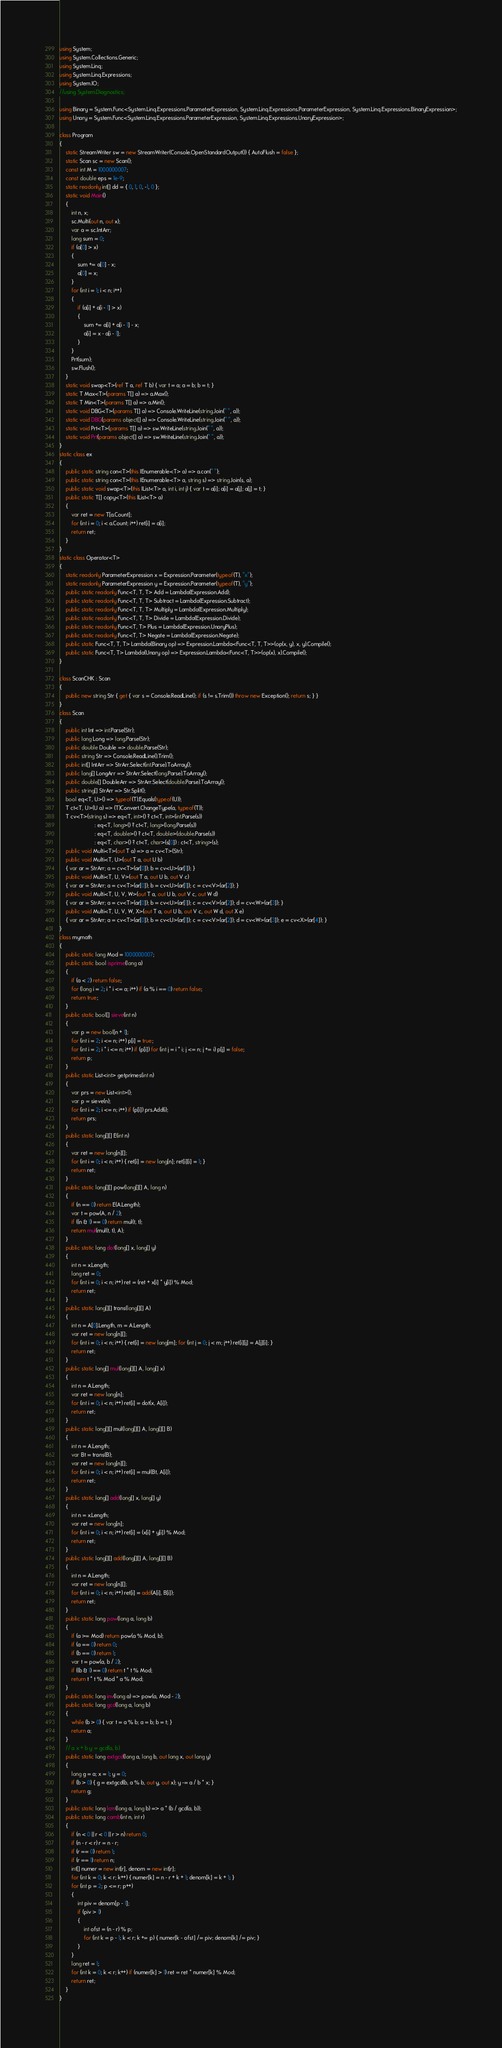<code> <loc_0><loc_0><loc_500><loc_500><_C#_>using System;
using System.Collections.Generic;
using System.Linq;
using System.Linq.Expressions;
using System.IO;
//using System.Diagnostics;

using Binary = System.Func<System.Linq.Expressions.ParameterExpression, System.Linq.Expressions.ParameterExpression, System.Linq.Expressions.BinaryExpression>;
using Unary = System.Func<System.Linq.Expressions.ParameterExpression, System.Linq.Expressions.UnaryExpression>;

class Program
{
    static StreamWriter sw = new StreamWriter(Console.OpenStandardOutput()) { AutoFlush = false };
    static Scan sc = new Scan();
    const int M = 1000000007;
    const double eps = 1e-9;
    static readonly int[] dd = { 0, 1, 0, -1, 0 };
    static void Main()
    {
        int n, x;
        sc.Multi(out n, out x);
        var a = sc.IntArr;
        long sum = 0;
        if (a[0] > x)
        {
            sum += a[0] - x;
            a[0] = x;
        }
        for (int i = 1; i < n; i++)
        {
            if (a[i] + a[i - 1] > x)
            {
                sum += a[i] + a[i - 1] - x;
                a[i] = x - a[i - 1];
            }
        }
        Prt(sum);
        sw.Flush();
    }
    static void swap<T>(ref T a, ref T b) { var t = a; a = b; b = t; }
    static T Max<T>(params T[] a) => a.Max();
    static T Min<T>(params T[] a) => a.Min();
    static void DBG<T>(params T[] a) => Console.WriteLine(string.Join(" ", a));
    static void DBG(params object[] a) => Console.WriteLine(string.Join(" ", a));
    static void Prt<T>(params T[] a) => sw.WriteLine(string.Join(" ", a));
    static void Prt(params object[] a) => sw.WriteLine(string.Join(" ", a));
}
static class ex
{
    public static string con<T>(this IEnumerable<T> a) => a.con(" ");
    public static string con<T>(this IEnumerable<T> a, string s) => string.Join(s, a);
    public static void swap<T>(this IList<T> a, int i, int j) { var t = a[i]; a[i] = a[j]; a[j] = t; }
    public static T[] copy<T>(this IList<T> a)
    {
        var ret = new T[a.Count];
        for (int i = 0; i < a.Count; i++) ret[i] = a[i];
        return ret;
    }
}
static class Operator<T>
{
    static readonly ParameterExpression x = Expression.Parameter(typeof(T), "x");
    static readonly ParameterExpression y = Expression.Parameter(typeof(T), "y");
    public static readonly Func<T, T, T> Add = Lambda(Expression.Add);
    public static readonly Func<T, T, T> Subtract = Lambda(Expression.Subtract);
    public static readonly Func<T, T, T> Multiply = Lambda(Expression.Multiply);
    public static readonly Func<T, T, T> Divide = Lambda(Expression.Divide);
    public static readonly Func<T, T> Plus = Lambda(Expression.UnaryPlus);
    public static readonly Func<T, T> Negate = Lambda(Expression.Negate);
    public static Func<T, T, T> Lambda(Binary op) => Expression.Lambda<Func<T, T, T>>(op(x, y), x, y).Compile();
    public static Func<T, T> Lambda(Unary op) => Expression.Lambda<Func<T, T>>(op(x), x).Compile();
}

class ScanCHK : Scan
{
    public new string Str { get { var s = Console.ReadLine(); if (s != s.Trim()) throw new Exception(); return s; } }
}
class Scan
{
    public int Int => int.Parse(Str);
    public long Long => long.Parse(Str);
    public double Double => double.Parse(Str);
    public string Str => Console.ReadLine().Trim();
    public int[] IntArr => StrArr.Select(int.Parse).ToArray();
    public long[] LongArr => StrArr.Select(long.Parse).ToArray();
    public double[] DoubleArr => StrArr.Select(double.Parse).ToArray();
    public string[] StrArr => Str.Split();
    bool eq<T, U>() => typeof(T).Equals(typeof(U));
    T ct<T, U>(U a) => (T)Convert.ChangeType(a, typeof(T));
    T cv<T>(string s) => eq<T, int>() ? ct<T, int>(int.Parse(s))
                       : eq<T, long>() ? ct<T, long>(long.Parse(s))
                       : eq<T, double>() ? ct<T, double>(double.Parse(s))
                       : eq<T, char>() ? ct<T, char>(s[0]) : ct<T, string>(s);
    public void Multi<T>(out T a) => a = cv<T>(Str);
    public void Multi<T, U>(out T a, out U b)
    { var ar = StrArr; a = cv<T>(ar[0]); b = cv<U>(ar[1]); }
    public void Multi<T, U, V>(out T a, out U b, out V c)
    { var ar = StrArr; a = cv<T>(ar[0]); b = cv<U>(ar[1]); c = cv<V>(ar[2]); }
    public void Multi<T, U, V, W>(out T a, out U b, out V c, out W d)
    { var ar = StrArr; a = cv<T>(ar[0]); b = cv<U>(ar[1]); c = cv<V>(ar[2]); d = cv<W>(ar[3]); }
    public void Multi<T, U, V, W, X>(out T a, out U b, out V c, out W d, out X e)
    { var ar = StrArr; a = cv<T>(ar[0]); b = cv<U>(ar[1]); c = cv<V>(ar[2]); d = cv<W>(ar[3]); e = cv<X>(ar[4]); }
}
class mymath
{
    public static long Mod = 1000000007;
    public static bool isprime(long a)
    {
        if (a < 2) return false;
        for (long i = 2; i * i <= a; i++) if (a % i == 0) return false;
        return true;
    }
    public static bool[] sieve(int n)
    {
        var p = new bool[n + 1];
        for (int i = 2; i <= n; i++) p[i] = true;
        for (int i = 2; i * i <= n; i++) if (p[i]) for (int j = i * i; j <= n; j += i) p[j] = false;
        return p;
    }
    public static List<int> getprimes(int n)
    {
        var prs = new List<int>();
        var p = sieve(n);
        for (int i = 2; i <= n; i++) if (p[i]) prs.Add(i);
        return prs;
    }
    public static long[][] E(int n)
    {
        var ret = new long[n][];
        for (int i = 0; i < n; i++) { ret[i] = new long[n]; ret[i][i] = 1; }
        return ret;
    }
    public static long[][] pow(long[][] A, long n)
    {
        if (n == 0) return E(A.Length);
        var t = pow(A, n / 2);
        if ((n & 1) == 0) return mul(t, t);
        return mul(mul(t, t), A);
    }
    public static long dot(long[] x, long[] y)
    {
        int n = x.Length;
        long ret = 0;
        for (int i = 0; i < n; i++) ret = (ret + x[i] * y[i]) % Mod;
        return ret;
    }
    public static long[][] trans(long[][] A)
    {
        int n = A[0].Length, m = A.Length;
        var ret = new long[n][];
        for (int i = 0; i < n; i++) { ret[i] = new long[m]; for (int j = 0; j < m; j++) ret[i][j] = A[j][i]; }
        return ret;
    }
    public static long[] mul(long[][] A, long[] x)
    {
        int n = A.Length;
        var ret = new long[n];
        for (int i = 0; i < n; i++) ret[i] = dot(x, A[i]);
        return ret;
    }
    public static long[][] mul(long[][] A, long[][] B)
    {
        int n = A.Length;
        var Bt = trans(B);
        var ret = new long[n][];
        for (int i = 0; i < n; i++) ret[i] = mul(Bt, A[i]);
        return ret;
    }
    public static long[] add(long[] x, long[] y)
    {
        int n = x.Length;
        var ret = new long[n];
        for (int i = 0; i < n; i++) ret[i] = (x[i] + y[i]) % Mod;
        return ret;
    }
    public static long[][] add(long[][] A, long[][] B)
    {
        int n = A.Length;
        var ret = new long[n][];
        for (int i = 0; i < n; i++) ret[i] = add(A[i], B[i]);
        return ret;
    }
    public static long pow(long a, long b)
    {
        if (a >= Mod) return pow(a % Mod, b);
        if (a == 0) return 0;
        if (b == 0) return 1;
        var t = pow(a, b / 2);
        if ((b & 1) == 0) return t * t % Mod;
        return t * t % Mod * a % Mod;
    }
    public static long inv(long a) => pow(a, Mod - 2);
    public static long gcd(long a, long b)
    {
        while (b > 0) { var t = a % b; a = b; b = t; }
        return a;
    }
    // a x + b y = gcd(a, b)
    public static long extgcd(long a, long b, out long x, out long y)
    {
        long g = a; x = 1; y = 0;
        if (b > 0) { g = extgcd(b, a % b, out y, out x); y -= a / b * x; }
        return g;
    }
    public static long lcm(long a, long b) => a * (b / gcd(a, b));
    public static long comb(int n, int r)
    {
        if (n < 0 || r < 0 || r > n) return 0;
        if (n - r < r) r = n - r;
        if (r == 0) return 1;
        if (r == 1) return n;
        int[] numer = new int[r], denom = new int[r];
        for (int k = 0; k < r; k++) { numer[k] = n - r + k + 1; denom[k] = k + 1; }
        for (int p = 2; p <= r; p++)
        {
            int piv = denom[p - 1];
            if (piv > 1)
            {
                int ofst = (n - r) % p;
                for (int k = p - 1; k < r; k += p) { numer[k - ofst] /= piv; denom[k] /= piv; }
            }
        }
        long ret = 1;
        for (int k = 0; k < r; k++) if (numer[k] > 1) ret = ret * numer[k] % Mod;
        return ret;
    }
}
</code> 